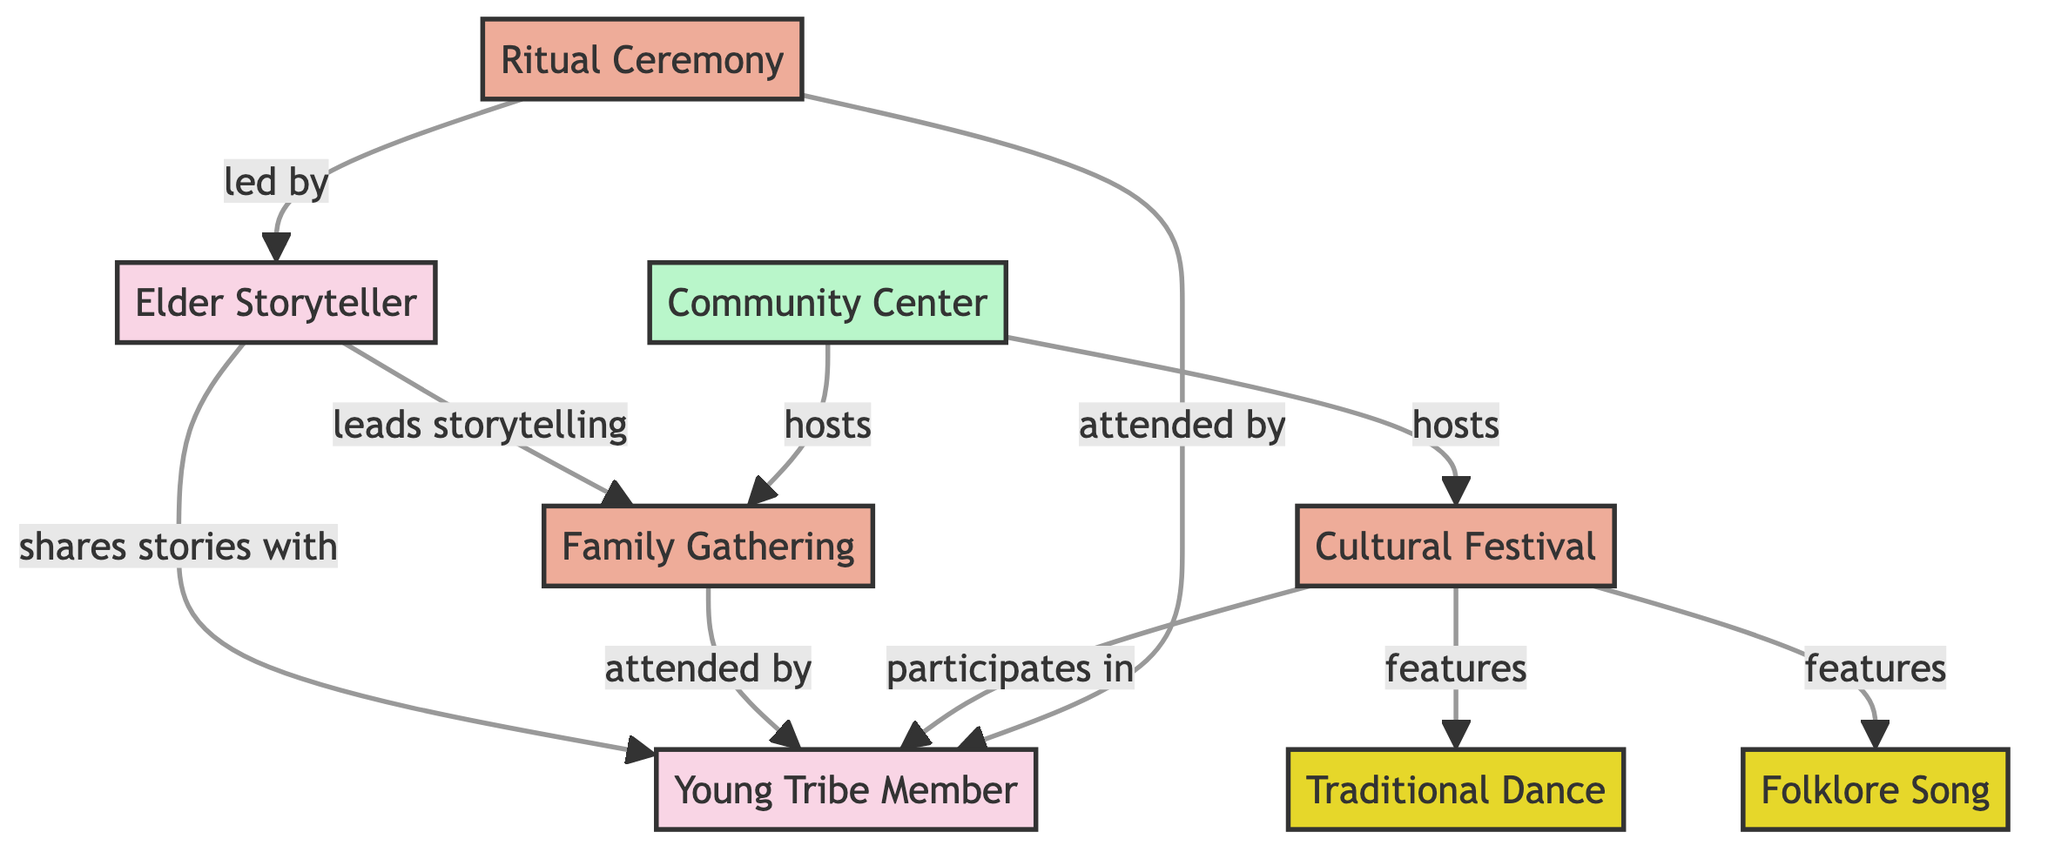What is the type of node that represents the Elder Storyteller? The Elder Storyteller is classified as a person in the diagram. This can be seen from the node's label and its assigned type.
Answer: person How many events are represented in the diagram? By reviewing the nodes labeled as events, there are four in total: Family Gathering, Cultural Festival, Ritual Ceremony, and an additional event not mentioned as part of the cultural activities.
Answer: 4 Who leads the storytelling at the Family Gathering? The Elder Storyteller leads the storytelling at the Family Gathering, as indicated by the edge connecting them with the label "leads storytelling."
Answer: Elder Storyteller Which event is participated in by the Young Tribe Member? The Young Tribe Member participates in the Cultural Festival, as shown by a direct edge linking them with the event labeled "participates in."
Answer: Cultural Festival What activities are featured during the Cultural Festival? The Cultural Festival features two activities: Traditional Dance and Folklore Song, displayed by the edges leading from the Cultural Festival to each of these nodes labeled "features."
Answer: Traditional Dance, Folklore Song How many individuals directly share folklore tales? There is one node that shares stories, which is the Elder Storyteller sharing stories with the Young Tribe Member. Thus, only one individual is directly involved in this storytelling process.
Answer: 1 Who attends the Ritual Ceremony? The Ritual Ceremony is attended by both the Elder Storyteller and the Young Tribe Member, based on the direct connections shown in the diagram.
Answer: Elder Storyteller, Young Tribe Member Where are both the Family Gathering and Cultural Festival hosted? Both the Family Gathering and Cultural Festival are hosted at the Community Center, which is indicated by edges labeled "hosts" linking the Community Center to both events.
Answer: Community Center Which node has the most connections as indicated by edges in the diagram? The Elder Storyteller has multiple connections with edges leading to the Young Tribe Member, Family Gathering, and Ritual Ceremony, indicating the highest number of direct relationships.
Answer: Elder Storyteller 